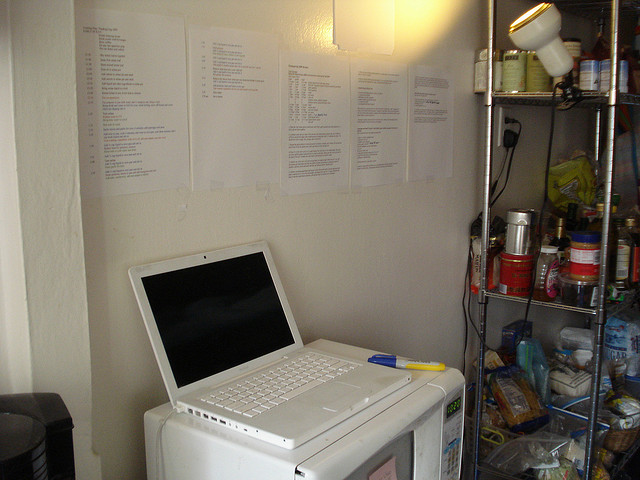Can you talk about the layout of the objects on the shelf? Certainly! The shelf on the right displays a variety of items organized in rows and stacks. There are multiple cans at differing heights, some stacked on top of each other. The shelf includes several jars, one of which appears to contain honey. The items are mostly grouped by type, indicating that this area might serve as a storage for food and kitchen essentials. 